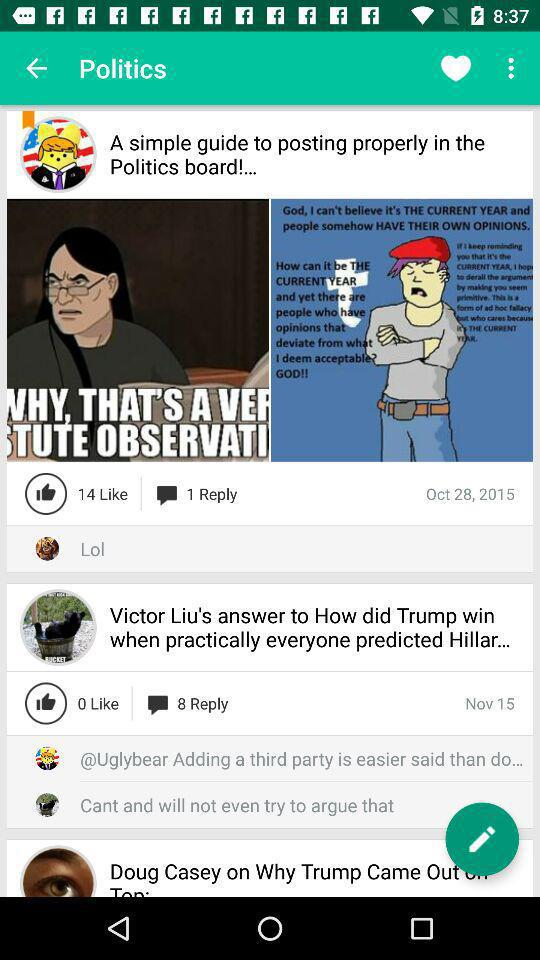How many people replied on the "A simple guide to posting properly in the Politics board!..."? There was 1 reply on the "A simple guide to posting properly in the Politics board!...". 